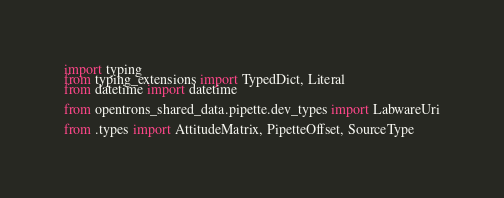<code> <loc_0><loc_0><loc_500><loc_500><_Python_>import typing
from typing_extensions import TypedDict, Literal
from datetime import datetime

from opentrons_shared_data.pipette.dev_types import LabwareUri

from .types import AttitudeMatrix, PipetteOffset, SourceType

</code> 